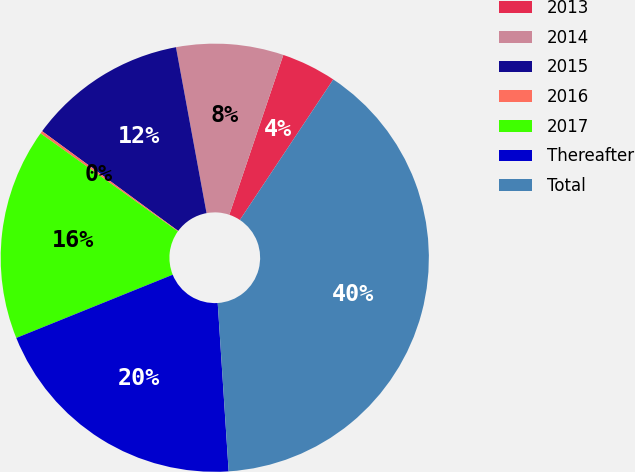Convert chart to OTSL. <chart><loc_0><loc_0><loc_500><loc_500><pie_chart><fcel>2013<fcel>2014<fcel>2015<fcel>2016<fcel>2017<fcel>Thereafter<fcel>Total<nl><fcel>4.15%<fcel>8.09%<fcel>12.03%<fcel>0.2%<fcel>15.98%<fcel>19.92%<fcel>39.63%<nl></chart> 